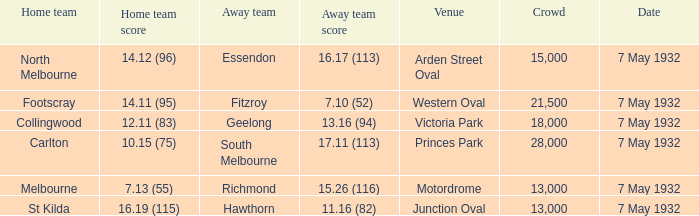What is the largest crowd with Away team score of 13.16 (94)? 18000.0. 